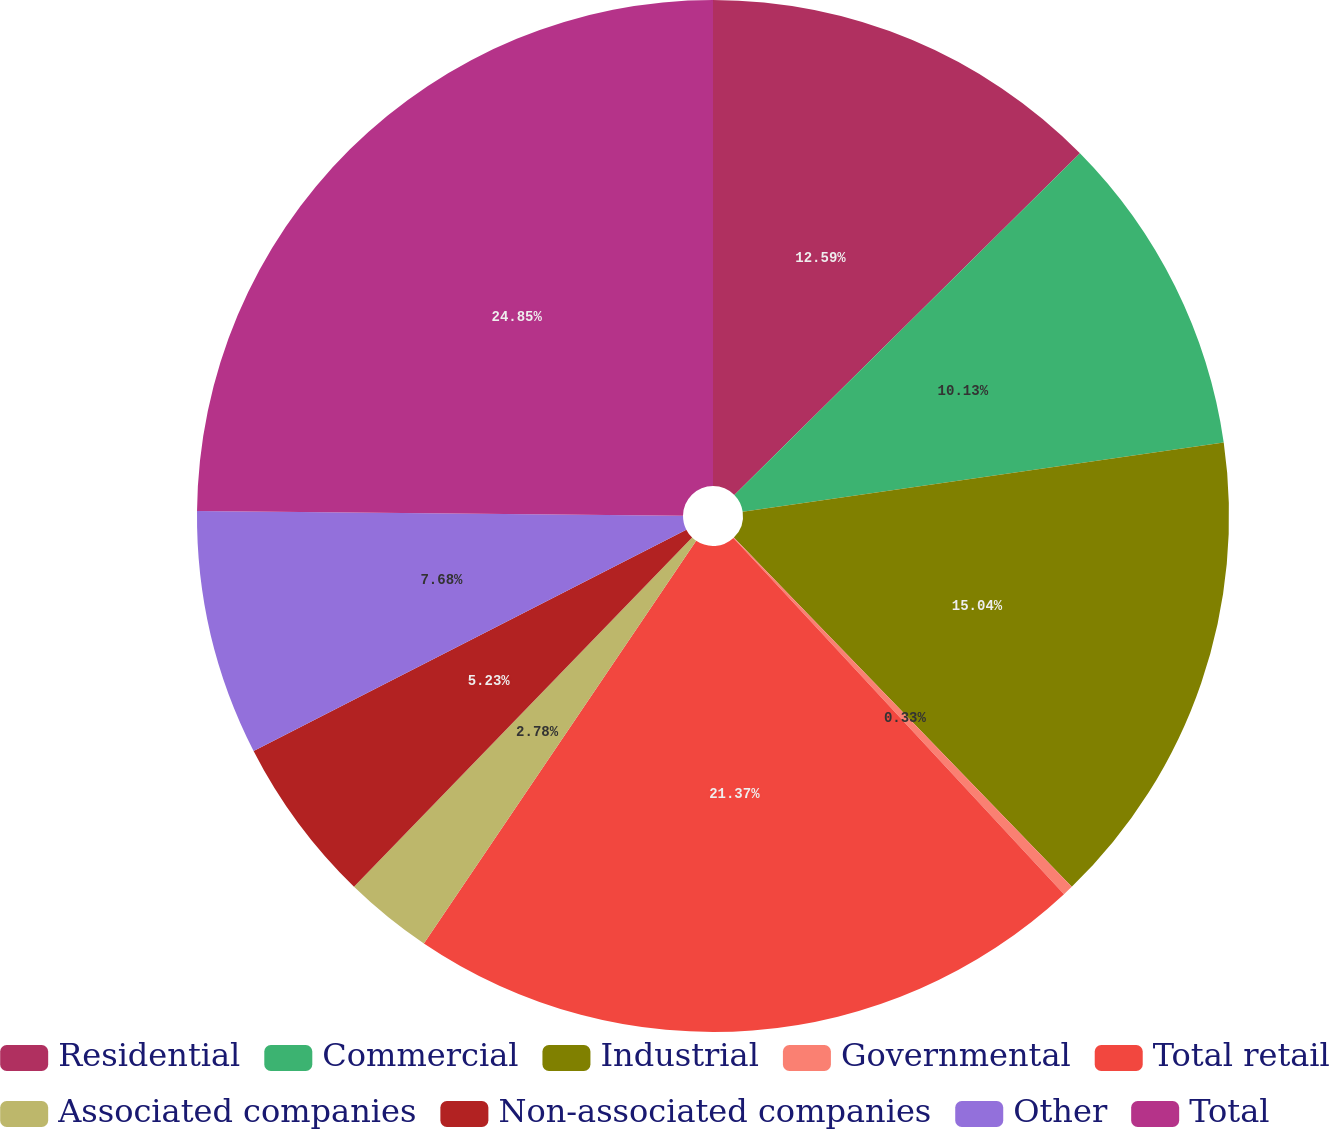Convert chart to OTSL. <chart><loc_0><loc_0><loc_500><loc_500><pie_chart><fcel>Residential<fcel>Commercial<fcel>Industrial<fcel>Governmental<fcel>Total retail<fcel>Associated companies<fcel>Non-associated companies<fcel>Other<fcel>Total<nl><fcel>12.59%<fcel>10.13%<fcel>15.04%<fcel>0.33%<fcel>21.37%<fcel>2.78%<fcel>5.23%<fcel>7.68%<fcel>24.84%<nl></chart> 